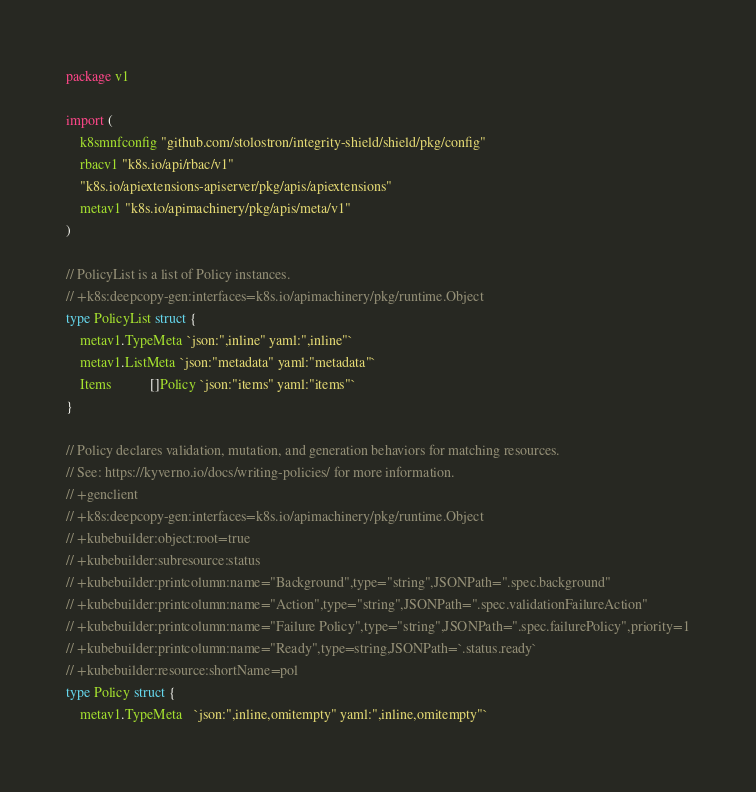<code> <loc_0><loc_0><loc_500><loc_500><_Go_>package v1

import (
	k8smnfconfig "github.com/stolostron/integrity-shield/shield/pkg/config"
	rbacv1 "k8s.io/api/rbac/v1"
	"k8s.io/apiextensions-apiserver/pkg/apis/apiextensions"
	metav1 "k8s.io/apimachinery/pkg/apis/meta/v1"
)

// PolicyList is a list of Policy instances.
// +k8s:deepcopy-gen:interfaces=k8s.io/apimachinery/pkg/runtime.Object
type PolicyList struct {
	metav1.TypeMeta `json:",inline" yaml:",inline"`
	metav1.ListMeta `json:"metadata" yaml:"metadata"`
	Items           []Policy `json:"items" yaml:"items"`
}

// Policy declares validation, mutation, and generation behaviors for matching resources.
// See: https://kyverno.io/docs/writing-policies/ for more information.
// +genclient
// +k8s:deepcopy-gen:interfaces=k8s.io/apimachinery/pkg/runtime.Object
// +kubebuilder:object:root=true
// +kubebuilder:subresource:status
// +kubebuilder:printcolumn:name="Background",type="string",JSONPath=".spec.background"
// +kubebuilder:printcolumn:name="Action",type="string",JSONPath=".spec.validationFailureAction"
// +kubebuilder:printcolumn:name="Failure Policy",type="string",JSONPath=".spec.failurePolicy",priority=1
// +kubebuilder:printcolumn:name="Ready",type=string,JSONPath=`.status.ready`
// +kubebuilder:resource:shortName=pol
type Policy struct {
	metav1.TypeMeta   `json:",inline,omitempty" yaml:",inline,omitempty"`</code> 